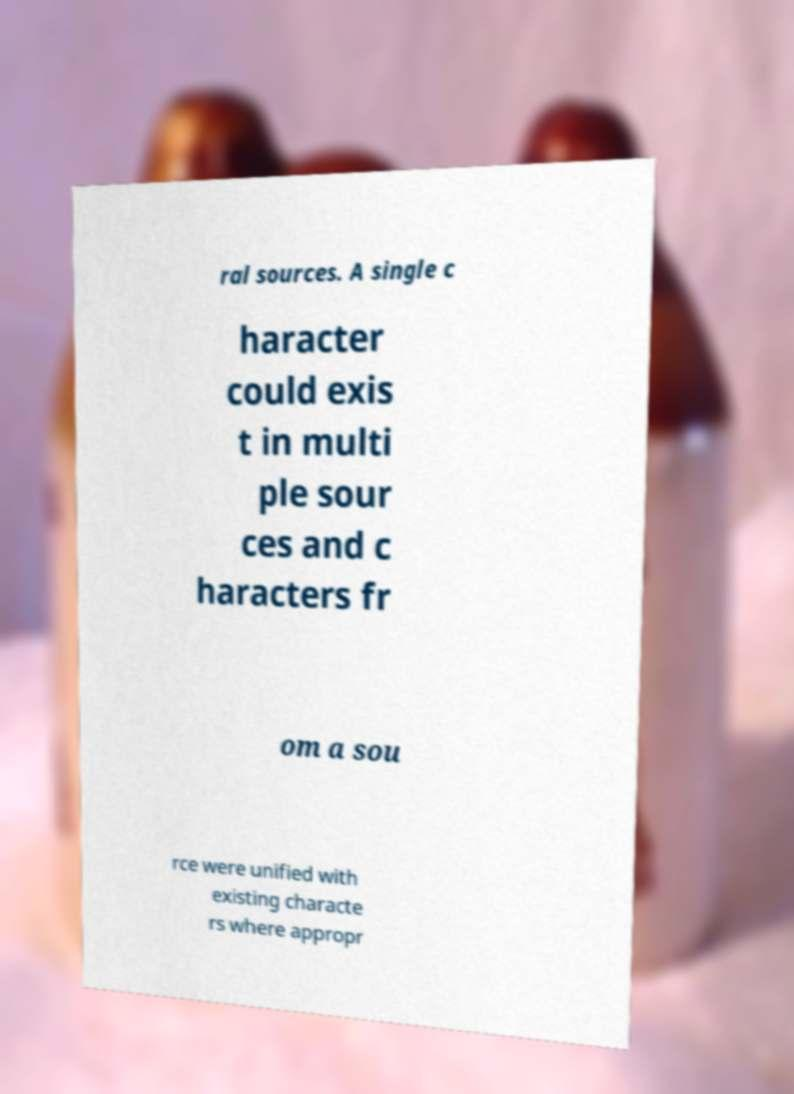There's text embedded in this image that I need extracted. Can you transcribe it verbatim? ral sources. A single c haracter could exis t in multi ple sour ces and c haracters fr om a sou rce were unified with existing characte rs where appropr 